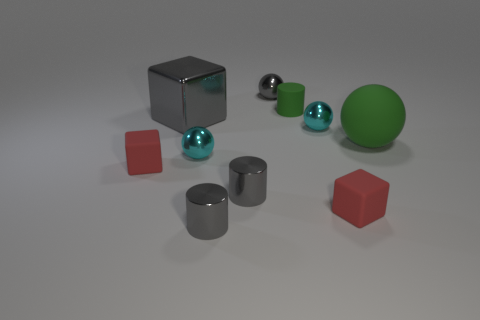Subtract all gray metallic cylinders. How many cylinders are left? 1 Subtract all green cylinders. How many cylinders are left? 2 Subtract all cyan cylinders. How many cyan balls are left? 2 Subtract 1 gray blocks. How many objects are left? 9 Subtract all balls. How many objects are left? 6 Subtract 1 blocks. How many blocks are left? 2 Subtract all red cylinders. Subtract all red balls. How many cylinders are left? 3 Subtract all small cyan metal spheres. Subtract all small gray cylinders. How many objects are left? 6 Add 4 gray cylinders. How many gray cylinders are left? 6 Add 5 tiny red matte objects. How many tiny red matte objects exist? 7 